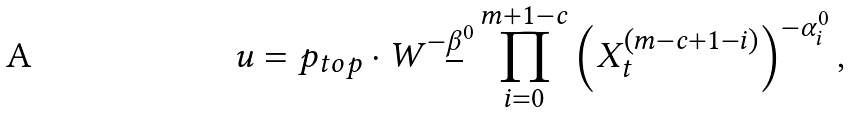<formula> <loc_0><loc_0><loc_500><loc_500>u = p _ { t o p } \cdot W ^ { - \underline { \beta } ^ { 0 } } \prod _ { i = 0 } ^ { m + 1 - c } \left ( X _ { t } ^ { ( m - c + 1 - i ) } \right ) ^ { - \alpha ^ { 0 } _ { i } } ,</formula> 